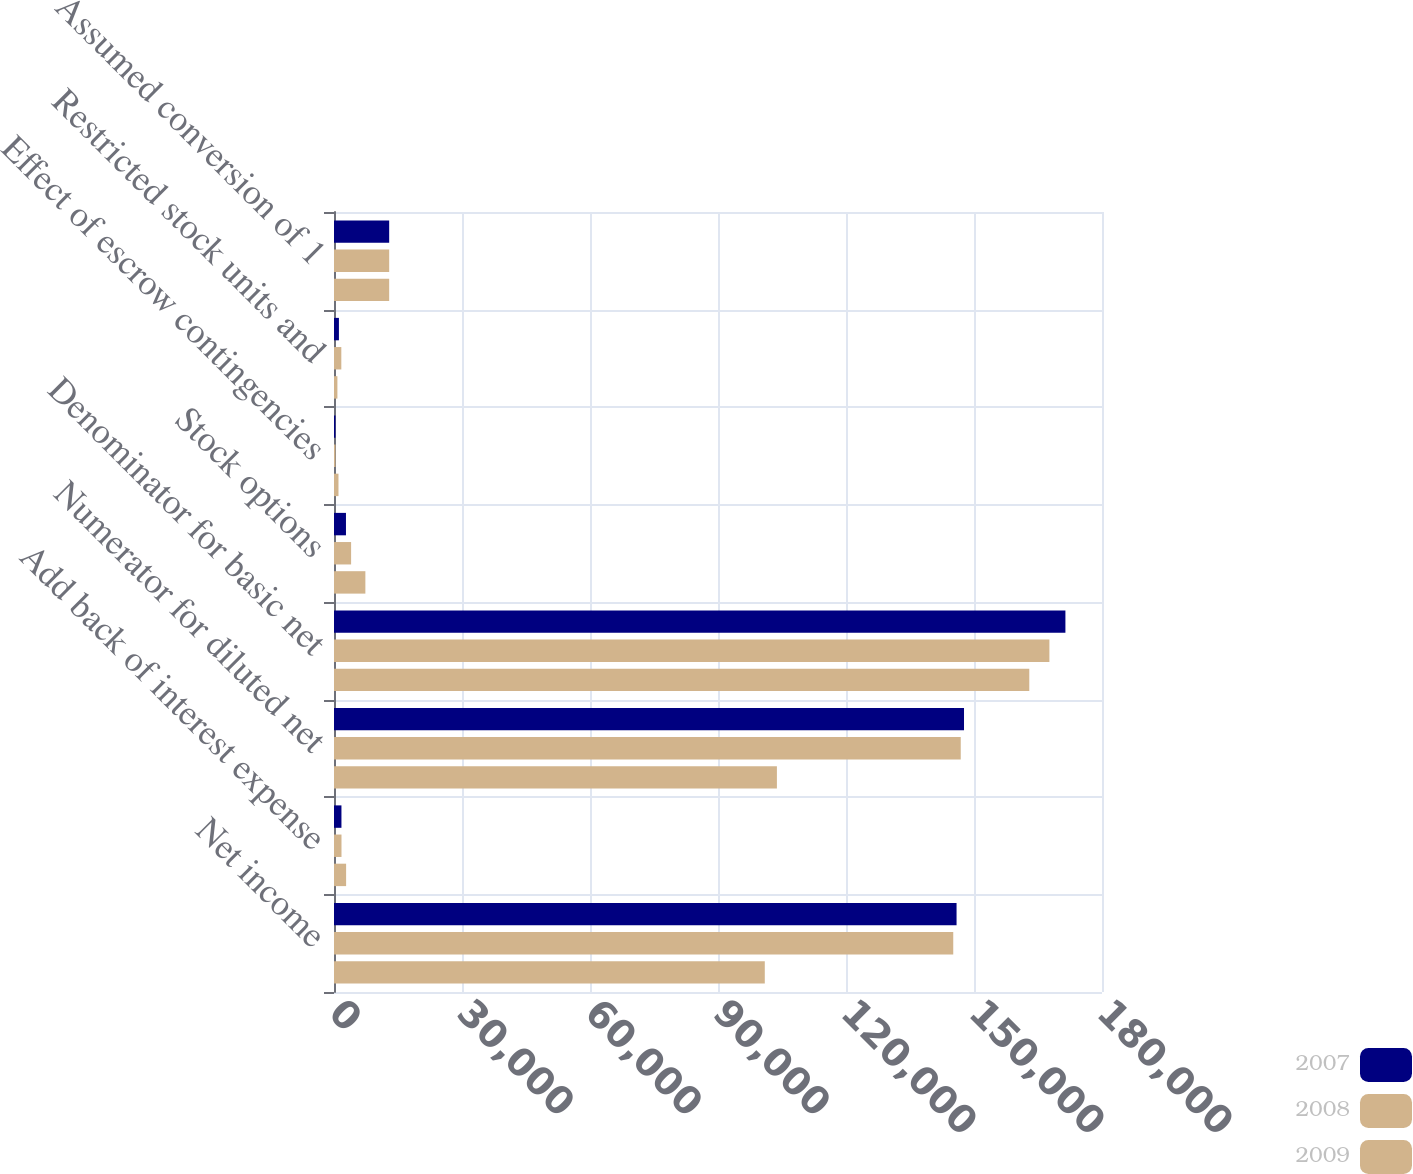<chart> <loc_0><loc_0><loc_500><loc_500><stacked_bar_chart><ecel><fcel>Net income<fcel>Add back of interest expense<fcel>Numerator for diluted net<fcel>Denominator for basic net<fcel>Stock options<fcel>Effect of escrow contingencies<fcel>Restricted stock units and<fcel>Assumed conversion of 1<nl><fcel>2007<fcel>145913<fcel>1746<fcel>147659<fcel>171425<fcel>2805<fcel>342<fcel>1153<fcel>12933<nl><fcel>2008<fcel>145138<fcel>1757<fcel>146895<fcel>167673<fcel>4009<fcel>351<fcel>1716<fcel>12936<nl><fcel>2009<fcel>100967<fcel>2840<fcel>103807<fcel>162959<fcel>7354<fcel>1051<fcel>798<fcel>12932<nl></chart> 